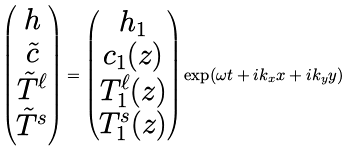Convert formula to latex. <formula><loc_0><loc_0><loc_500><loc_500>\begin{pmatrix} h \\ \tilde { c } \\ \tilde { T } ^ { \ell } \\ \tilde { T } ^ { s } \end{pmatrix} = \begin{pmatrix} h _ { 1 } \\ c _ { 1 } ( z ) \\ T ^ { \ell } _ { 1 } ( z ) \\ T ^ { s } _ { 1 } ( z ) \end{pmatrix} \exp ( \omega t + i k _ { x } x + i k _ { y } y )</formula> 